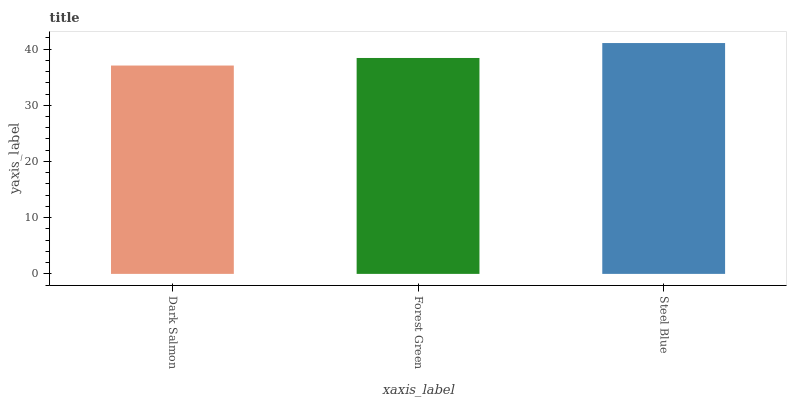Is Dark Salmon the minimum?
Answer yes or no. Yes. Is Steel Blue the maximum?
Answer yes or no. Yes. Is Forest Green the minimum?
Answer yes or no. No. Is Forest Green the maximum?
Answer yes or no. No. Is Forest Green greater than Dark Salmon?
Answer yes or no. Yes. Is Dark Salmon less than Forest Green?
Answer yes or no. Yes. Is Dark Salmon greater than Forest Green?
Answer yes or no. No. Is Forest Green less than Dark Salmon?
Answer yes or no. No. Is Forest Green the high median?
Answer yes or no. Yes. Is Forest Green the low median?
Answer yes or no. Yes. Is Dark Salmon the high median?
Answer yes or no. No. Is Steel Blue the low median?
Answer yes or no. No. 